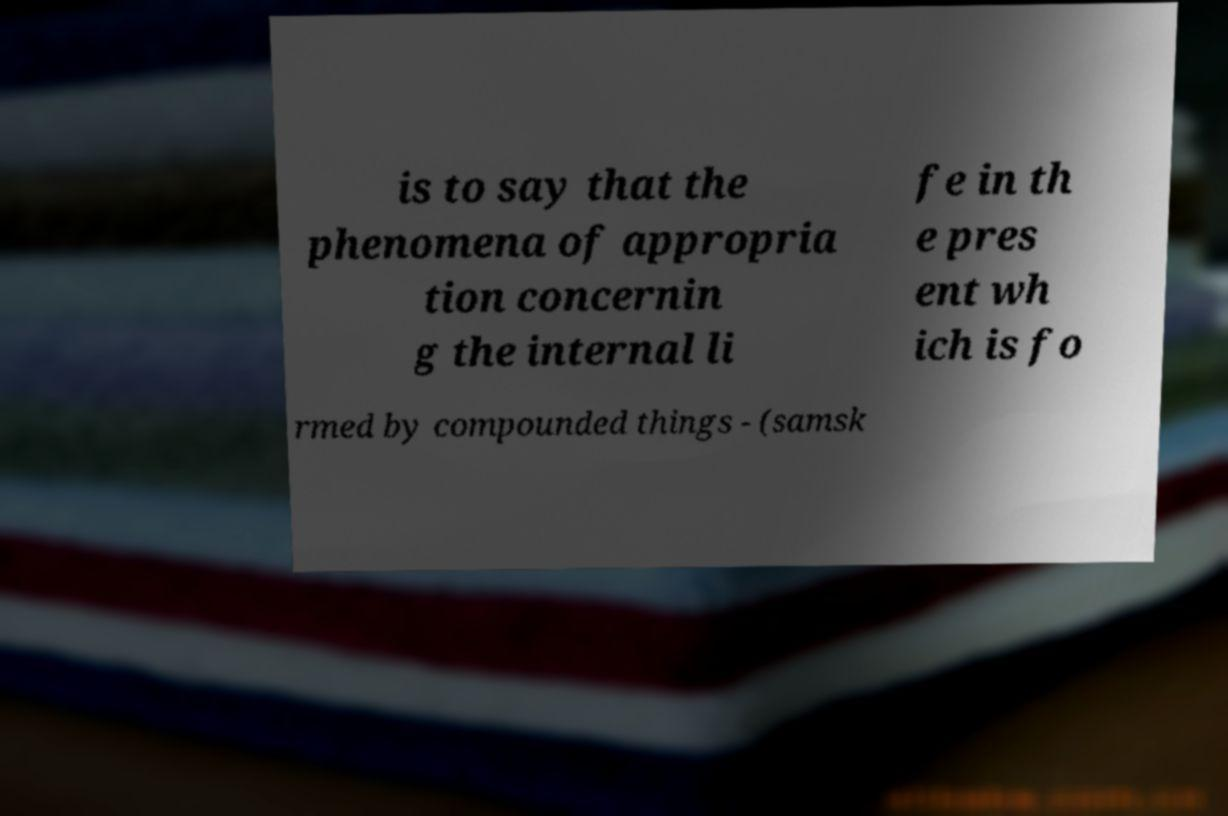Please identify and transcribe the text found in this image. is to say that the phenomena of appropria tion concernin g the internal li fe in th e pres ent wh ich is fo rmed by compounded things - (samsk 